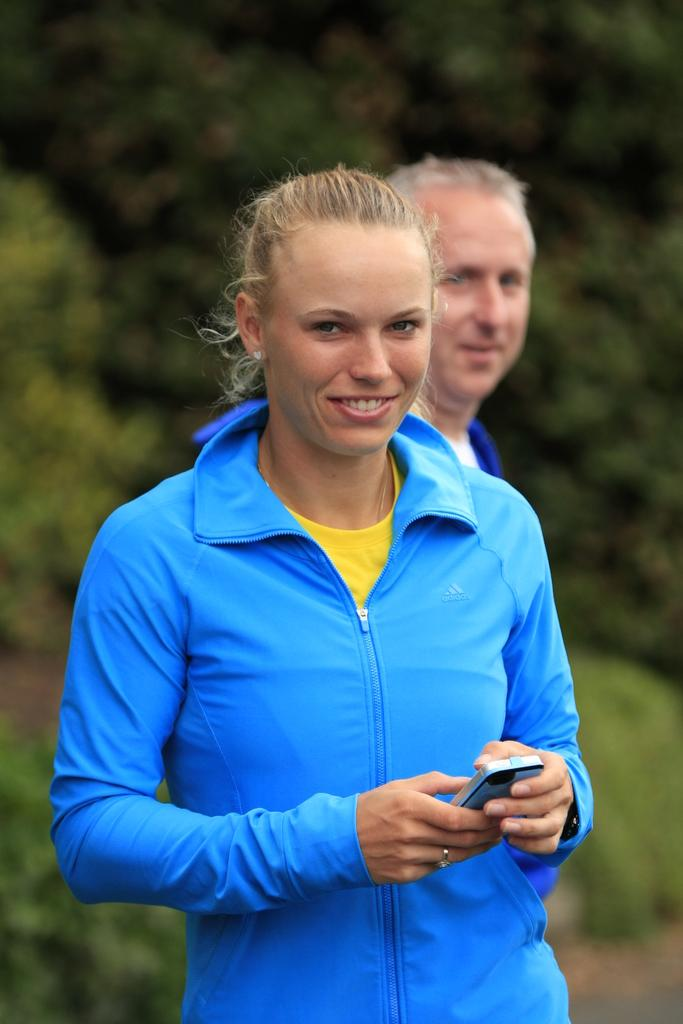Who is the main subject in the foreground of the image? There is a woman in the foreground of the image. What is the woman holding in the image? The woman is holding a mobile phone. What is the woman's facial expression in the image? The woman is smiling. Who can be seen in the background of the image? There is a man in the background of the image. What type of natural scenery is visible in the background of the image? There are trees in the background of the image. What note is the woman singing in the image? There is no indication in the image that the woman is singing, and therefore no note can be determined. 